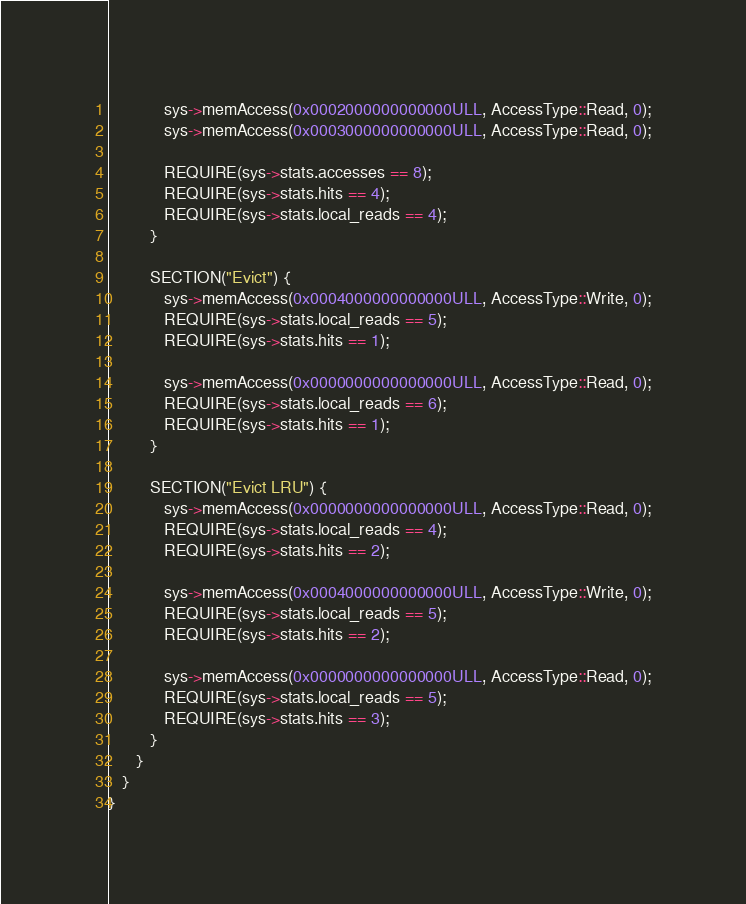Convert code to text. <code><loc_0><loc_0><loc_500><loc_500><_C++_>            sys->memAccess(0x0002000000000000ULL, AccessType::Read, 0);
            sys->memAccess(0x0003000000000000ULL, AccessType::Read, 0);

            REQUIRE(sys->stats.accesses == 8);
            REQUIRE(sys->stats.hits == 4);
            REQUIRE(sys->stats.local_reads == 4);
         }

         SECTION("Evict") {
            sys->memAccess(0x0004000000000000ULL, AccessType::Write, 0);
            REQUIRE(sys->stats.local_reads == 5);
            REQUIRE(sys->stats.hits == 1);

            sys->memAccess(0x0000000000000000ULL, AccessType::Read, 0);
            REQUIRE(sys->stats.local_reads == 6);
            REQUIRE(sys->stats.hits == 1);
         }

         SECTION("Evict LRU") {
            sys->memAccess(0x0000000000000000ULL, AccessType::Read, 0);
            REQUIRE(sys->stats.local_reads == 4);
            REQUIRE(sys->stats.hits == 2);

            sys->memAccess(0x0004000000000000ULL, AccessType::Write, 0);
            REQUIRE(sys->stats.local_reads == 5);
            REQUIRE(sys->stats.hits == 2);

            sys->memAccess(0x0000000000000000ULL, AccessType::Read, 0);
            REQUIRE(sys->stats.local_reads == 5);
            REQUIRE(sys->stats.hits == 3);
         }
      }
   }
}
</code> 